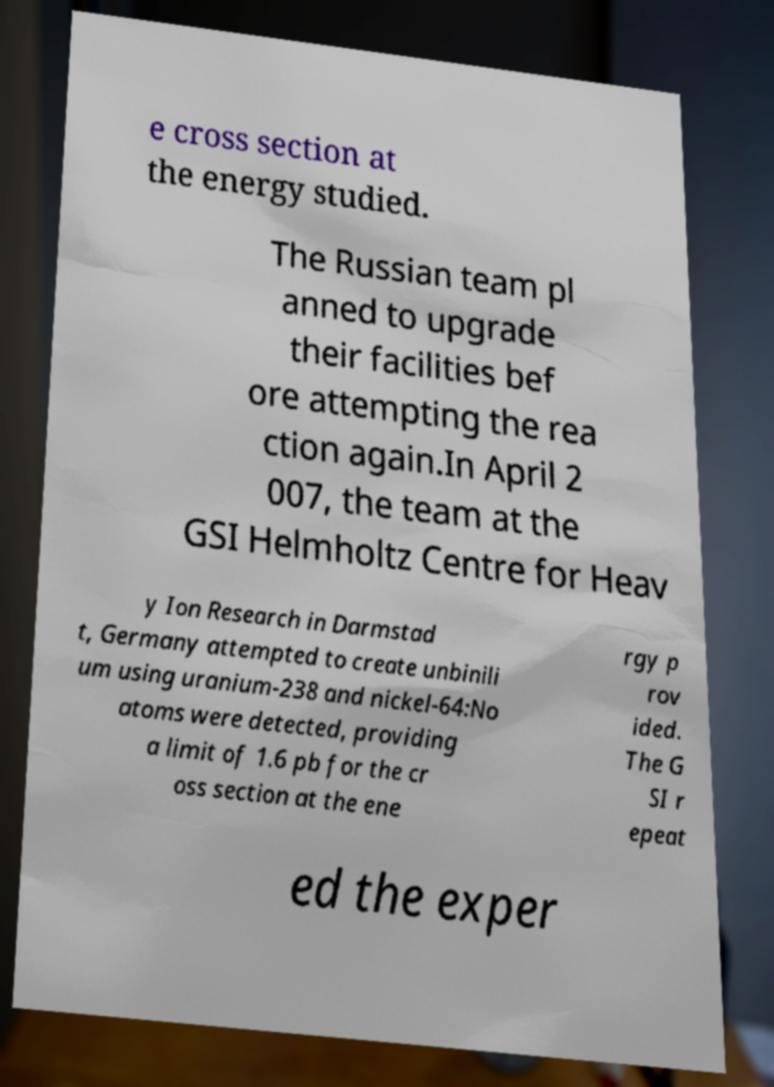For documentation purposes, I need the text within this image transcribed. Could you provide that? e cross section at the energy studied. The Russian team pl anned to upgrade their facilities bef ore attempting the rea ction again.In April 2 007, the team at the GSI Helmholtz Centre for Heav y Ion Research in Darmstad t, Germany attempted to create unbinili um using uranium-238 and nickel-64:No atoms were detected, providing a limit of 1.6 pb for the cr oss section at the ene rgy p rov ided. The G SI r epeat ed the exper 